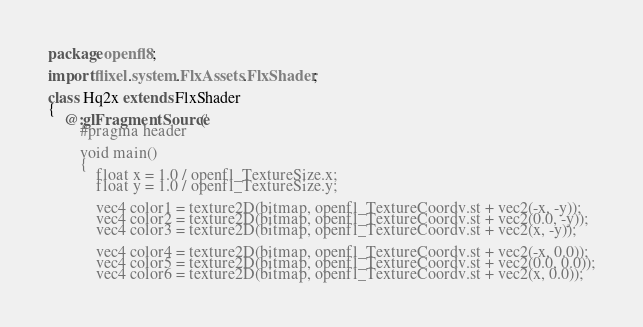<code> <loc_0><loc_0><loc_500><loc_500><_Haxe_>package openfl8;

import flixel.system.FlxAssets.FlxShader;

class Hq2x extends FlxShader
{
	@:glFragmentSource('
		#pragma header

		void main()
		{
			float x = 1.0 / openfl_TextureSize.x;
			float y = 1.0 / openfl_TextureSize.y;

			vec4 color1 = texture2D(bitmap, openfl_TextureCoordv.st + vec2(-x, -y));
			vec4 color2 = texture2D(bitmap, openfl_TextureCoordv.st + vec2(0.0, -y));
			vec4 color3 = texture2D(bitmap, openfl_TextureCoordv.st + vec2(x, -y));

			vec4 color4 = texture2D(bitmap, openfl_TextureCoordv.st + vec2(-x, 0.0));
			vec4 color5 = texture2D(bitmap, openfl_TextureCoordv.st + vec2(0.0, 0.0));
			vec4 color6 = texture2D(bitmap, openfl_TextureCoordv.st + vec2(x, 0.0));
</code> 